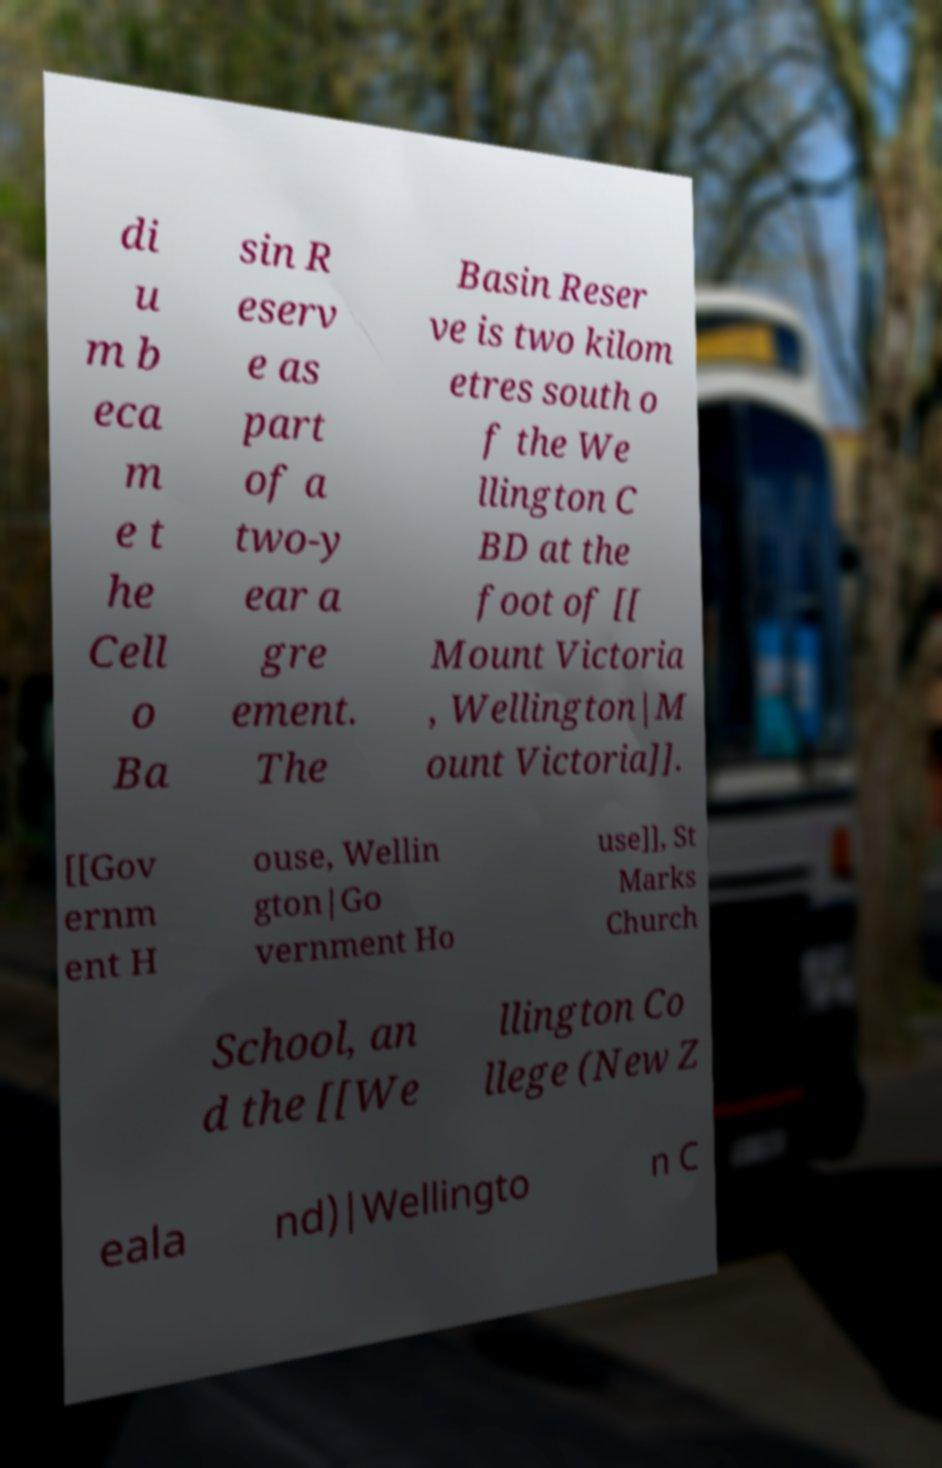There's text embedded in this image that I need extracted. Can you transcribe it verbatim? di u m b eca m e t he Cell o Ba sin R eserv e as part of a two-y ear a gre ement. The Basin Reser ve is two kilom etres south o f the We llington C BD at the foot of [[ Mount Victoria , Wellington|M ount Victoria]]. [[Gov ernm ent H ouse, Wellin gton|Go vernment Ho use]], St Marks Church School, an d the [[We llington Co llege (New Z eala nd)|Wellingto n C 